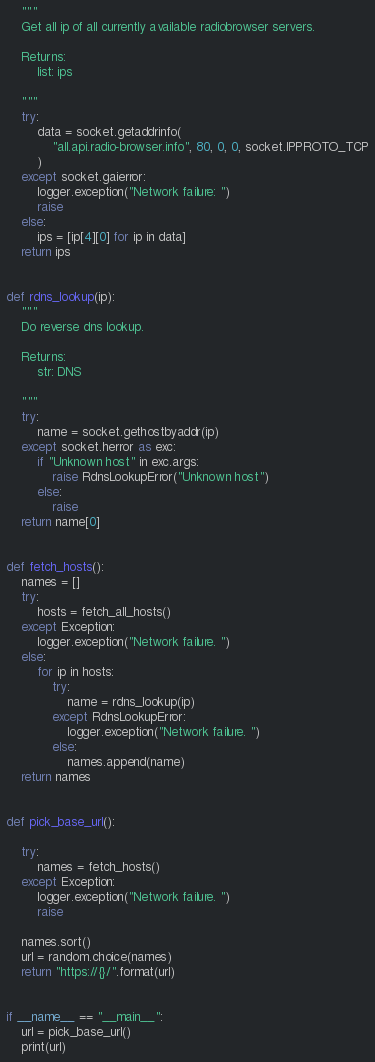Convert code to text. <code><loc_0><loc_0><loc_500><loc_500><_Python_>    """
    Get all ip of all currently available radiobrowser servers.

    Returns:
        list: ips

    """
    try:
        data = socket.getaddrinfo(
            "all.api.radio-browser.info", 80, 0, 0, socket.IPPROTO_TCP
        )
    except socket.gaierror:
        logger.exception("Network failure: ")
        raise
    else:
        ips = [ip[4][0] for ip in data]
    return ips


def rdns_lookup(ip):
    """
    Do reverse dns lookup.

    Returns:
        str: DNS

    """
    try:
        name = socket.gethostbyaddr(ip)
    except socket.herror as exc:
        if "Unknown host" in exc.args:
            raise RdnsLookupError("Unknown host")
        else:
            raise
    return name[0]


def fetch_hosts():
    names = []
    try:
        hosts = fetch_all_hosts()
    except Exception:
        logger.exception("Network failure. ")
    else:
        for ip in hosts:
            try:
                name = rdns_lookup(ip)
            except RdnsLookupError:
                logger.exception("Network failure. ")
            else:
                names.append(name)
    return names


def pick_base_url():

    try:
        names = fetch_hosts()
    except Exception:
        logger.exception("Network failure. ")
        raise

    names.sort()
    url = random.choice(names)
    return "https://{}/".format(url)


if __name__ == "__main__":
    url = pick_base_url()
    print(url)
</code> 